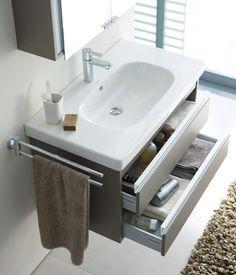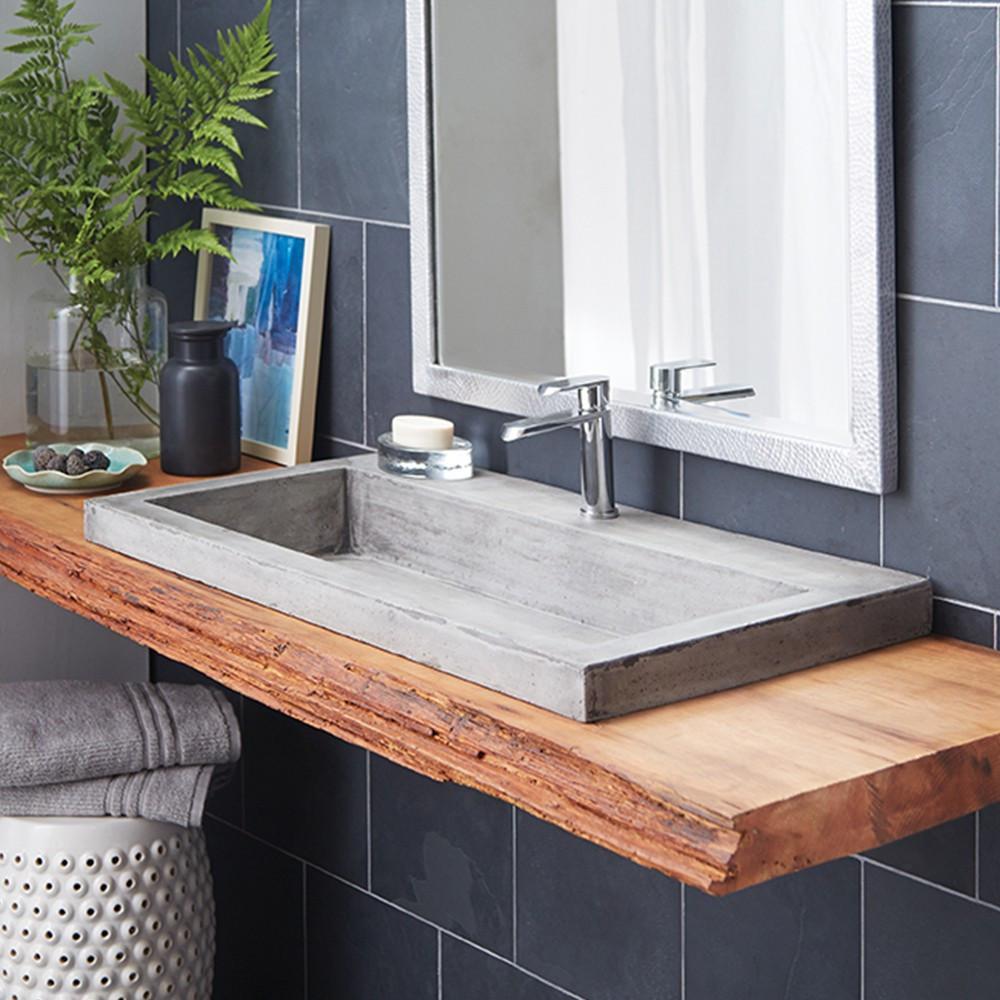The first image is the image on the left, the second image is the image on the right. Examine the images to the left and right. Is the description "A jar of fernlike foliage and a leaning framed picture are next to a rectangular gray sink mounted on a wood plank." accurate? Answer yes or no. Yes. The first image is the image on the left, the second image is the image on the right. Examine the images to the left and right. Is the description "The sink in one of the images is set into a brown wood hanging counter." accurate? Answer yes or no. Yes. 